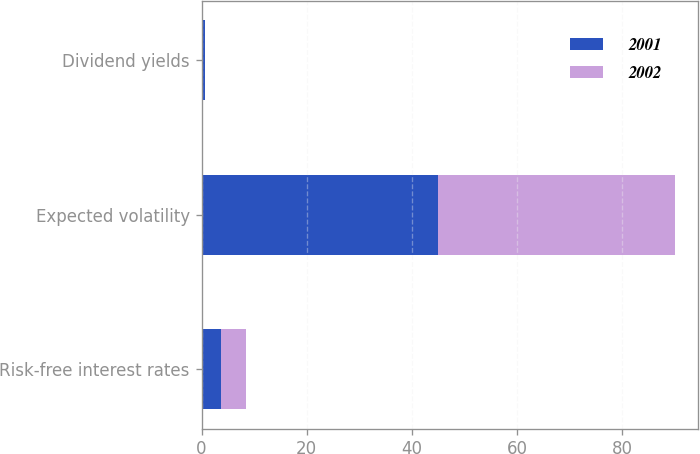Convert chart. <chart><loc_0><loc_0><loc_500><loc_500><stacked_bar_chart><ecel><fcel>Risk-free interest rates<fcel>Expected volatility<fcel>Dividend yields<nl><fcel>2001<fcel>3.75<fcel>45<fcel>0.7<nl><fcel>2002<fcel>4.8<fcel>45<fcel>0<nl></chart> 